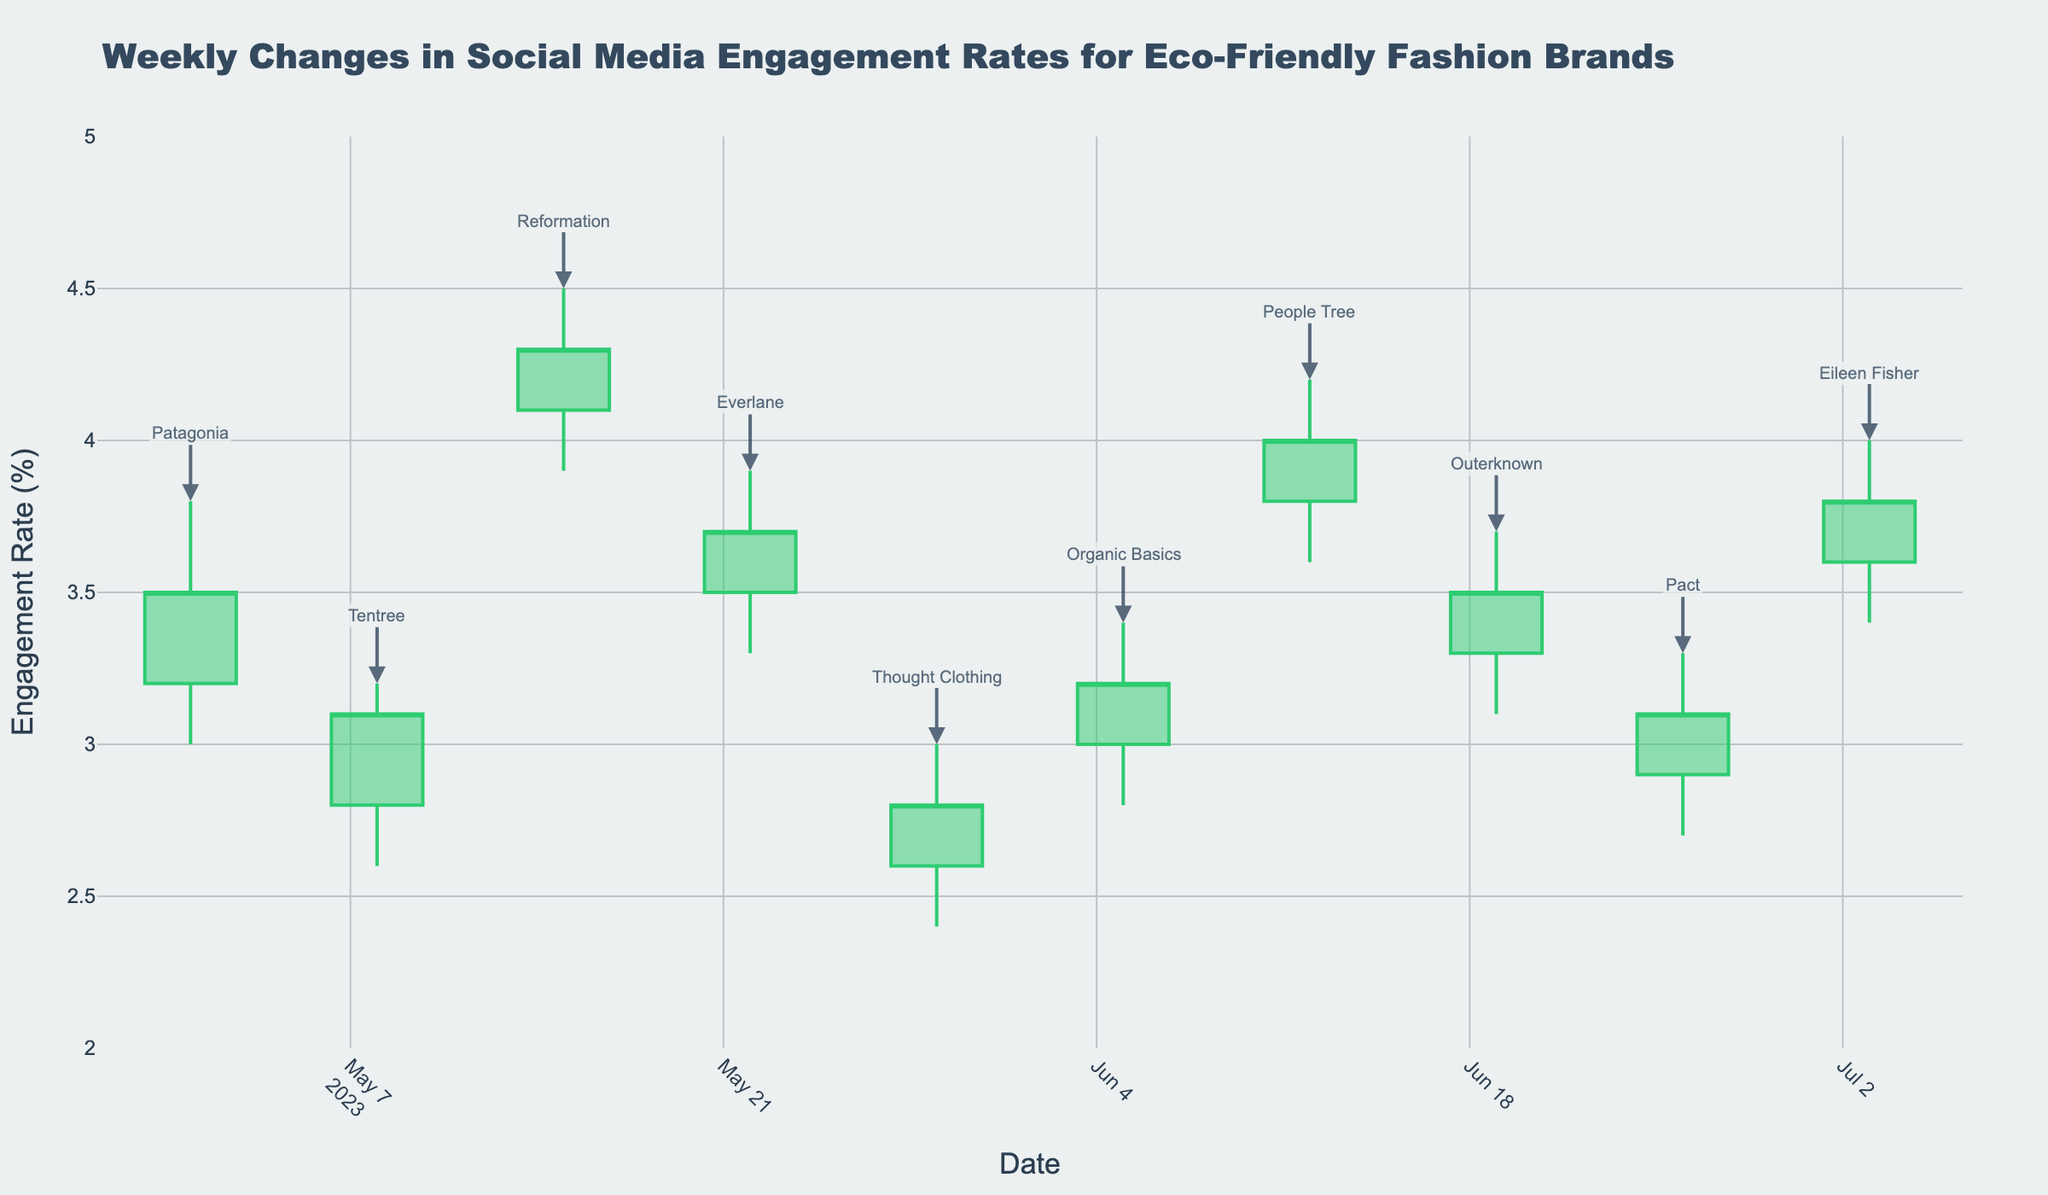What is the highest engagement rate observed in the given data? The highest engagement rate can be found by looking for the highest value in the "High" column of the data. Observing the figure, the highest engagement rate is for Reformation on 2023-05-15, which is 4.5%.
Answer: 4.5% Which brand had the lowest opening engagement rate, and what was it? To find the lowest opening engagement rate, we need to look at the "Open" values across all the data points. Observing the chart, Thought Clothing on 2023-05-29 had the lowest opening engagement rate at 2.6%.
Answer: Thought Clothing, 2.6% What is the overall trend for People Tree's engagement rates for the week of 2023-06-12? Observing the candlestick for People Tree on the figure, the opening engagement rate is 3.8%, the high is 4.2%, the low is 3.6%, and the closing is 4.0%. This indicates an upward trend during that week.
Answer: Upward trend Between Tentree and Pact, which brand showed a higher closing engagement rate, and what were the values? By looking at the closing rates, Tentree had a closing engagement rate of 3.1% on 2023-05-08, while Pact had a closing engagement rate of 3.1% on 2023-06-26. Both brands closed at the same engagement rate.
Answer: Both at 3.1% On which date did Everlane have its weekly engagement high, and what was the rate? To find Everlane's weekly engagement high, locate Everlane on the chart, which is on 2023-05-22. The high engagement rate for Everlane that week was 3.9%.
Answer: 2023-05-22, 3.9% Which brand had the smallest difference between its highest and lowest engagement rates for the week? To determine the smallest difference, we need to subtract the low rate from the high rate for each brand and compare these differences. Looking at the chart, Tentree (2023-05-08) has a high of 3.2% and a low of 2.6%, so the difference is 0.6%. This is the smallest difference among all brands.
Answer: Tentree, 0.6% Compared to Organic Basics, did Outerknown have a higher or lower average engagement rate for the week? What were these average rates? To find the average engagement rate, we calculate the mean of the opening, high, low, and closing rates for each brand. Organic Basics has an average = (3.0+3.4+2.8+3.2)/4 = 3.1. Outerknown has an average = (3.3+3.7+3.1+3.5)/4 = 3.4. Therefore, Outerknown had a higher average engagement rate.
Answer: Higher, Organic Basics 3.1%, Outerknown 3.4% How did Eileen Fisher's closing engagement rate compare to its opening rate for the week of 2023-07-03? Eileen Fisher had an opening rate of 3.6% and a closing rate of 3.8%. Comparing these, the closing rate is higher than the opening rate, indicating an increase.
Answer: The closing rate is higher What was the engagement rate range (difference between high and low) for Patagonia during the week of 2023-05-01? To find the engagement rate range, subtract the lowest rate from the highest rate for Patagonia. The high is 3.8% and the low is 3.0%, so the range is 3.8% - 3.0% = 0.8%.
Answer: 0.8% Which brand had the largest increase from its opening to closing engagement rate, and what was the increase? To determine this, calculate the difference between the closing and opening rates for each brand and find the largest increase. Reformation on 2023-05-15 had an opening rate of 4.1% and a closing rate of 4.3%, an increase of 0.2%. This is the largest increase.
Answer: Reformation, 0.2% 